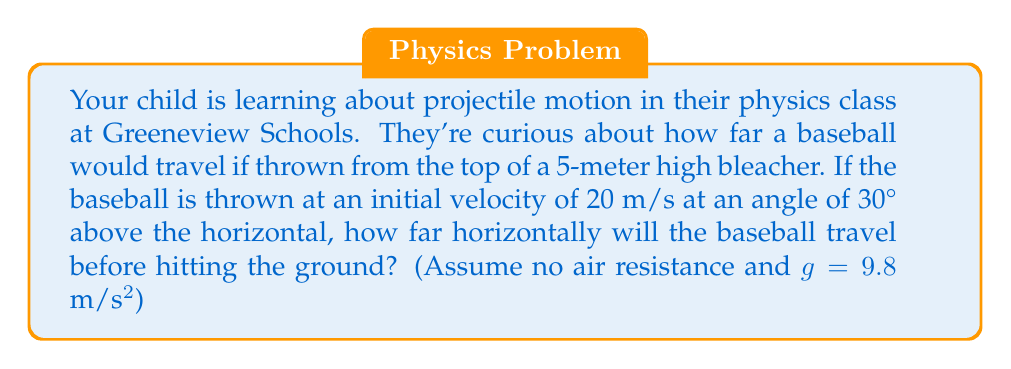Can you answer this question? Let's approach this step-by-step:

1) First, we need to decompose the initial velocity into its horizontal and vertical components:
   $v_{0x} = v_0 \cos \theta = 20 \cos 30° = 17.32$ m/s
   $v_{0y} = v_0 \sin \theta = 20 \sin 30° = 10$ m/s

2) The horizontal distance traveled is given by $x = v_{0x}t$, where $t$ is the time of flight.

3) To find $t$, we can use the vertical motion equation:
   $y = y_0 + v_{0y}t - \frac{1}{2}gt^2$

4) At the point of landing, $y = 0$ and $y_0 = 5$ (initial height). Substituting:
   $0 = 5 + 10t - \frac{1}{2}(9.8)t^2$

5) Rearranging:
   $4.9t^2 - 10t - 5 = 0$

6) This is a quadratic equation. We can solve it using the quadratic formula:
   $t = \frac{-b \pm \sqrt{b^2 - 4ac}}{2a}$

   Where $a = 4.9$, $b = -10$, and $c = -5$

7) Solving:
   $t = \frac{10 \pm \sqrt{100 + 98}}{9.8} = \frac{10 \pm 14.14}{9.8}$

8) We take the positive root as time can't be negative:
   $t = \frac{10 + 14.14}{9.8} = 2.46$ seconds

9) Now we can find the horizontal distance:
   $x = v_{0x}t = 17.32 * 2.46 = 42.61$ meters

Therefore, the baseball will travel approximately 42.61 meters horizontally before hitting the ground.
Answer: 42.61 meters 